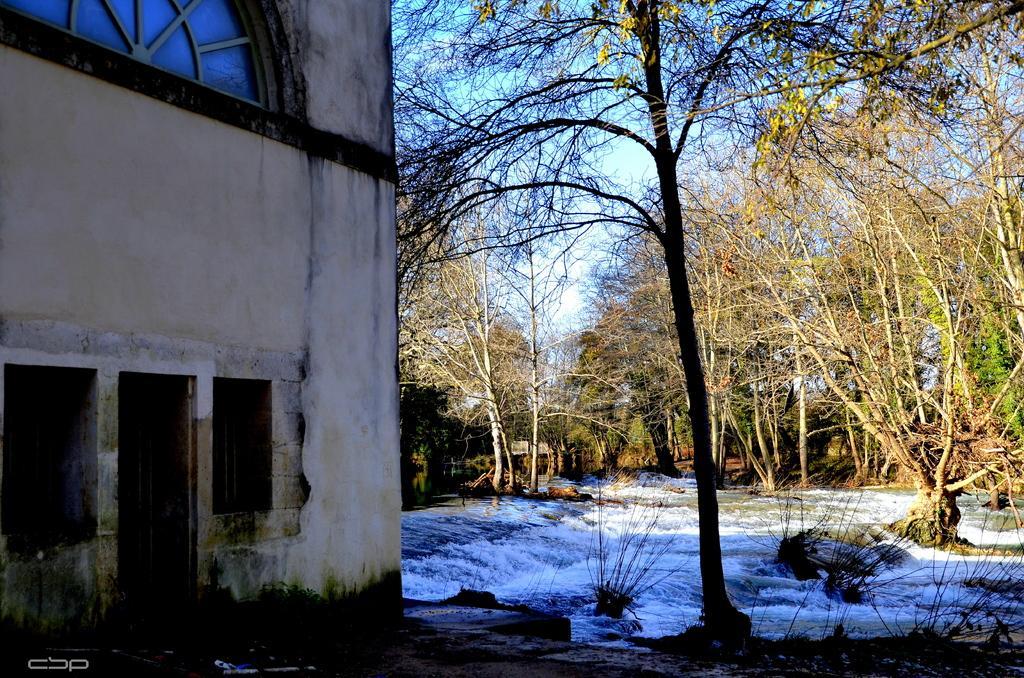Describe this image in one or two sentences. In this image we can see running water, rocks, trees, building and sky with clouds. 